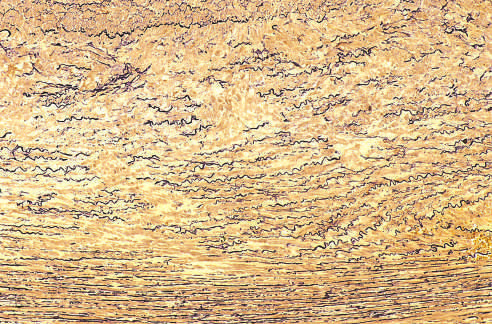did the cross-section of aortic media from a patient with marfan syndrome show marked elastin fragmentation and areas devoid of elastin that resemble cystic spaces?
Answer the question using a single word or phrase. Yes 